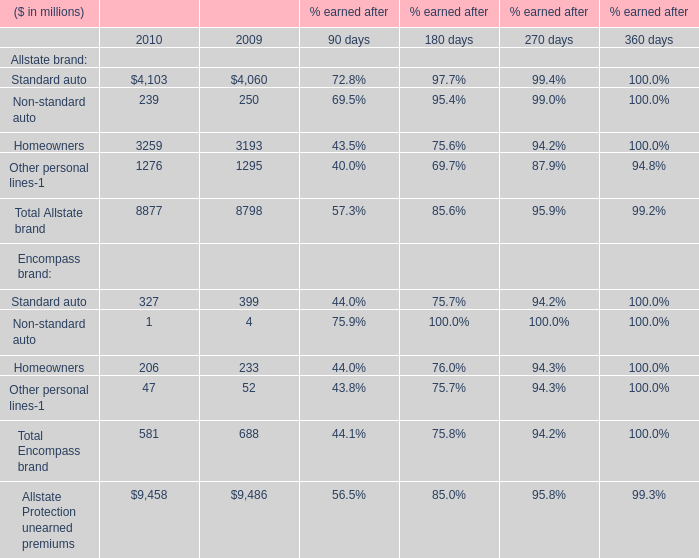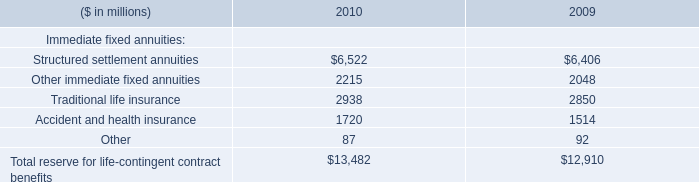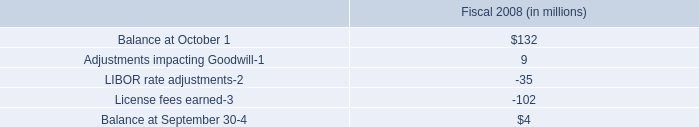What is the sum of Standard auto for Allstate brand in 2010 and Structured settlement annuities for Immediate fixed annuities in 2009? (in million) 
Computations: (6406 + 4103)
Answer: 10509.0. 